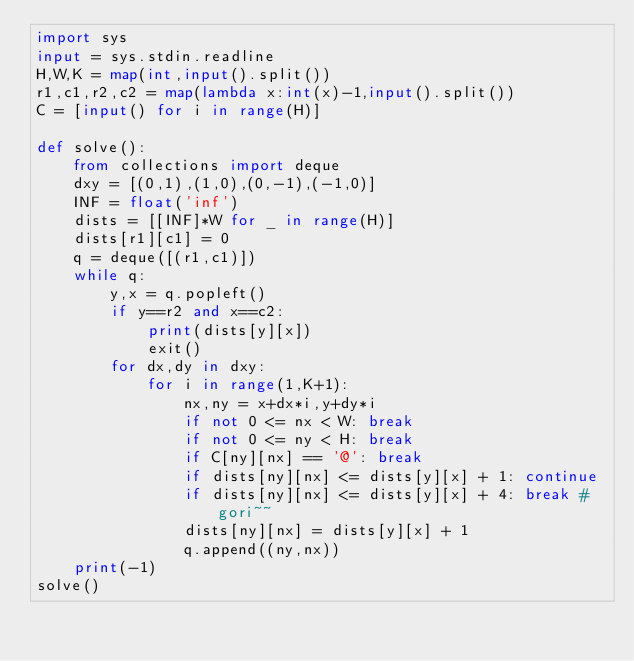Convert code to text. <code><loc_0><loc_0><loc_500><loc_500><_Python_>import sys
input = sys.stdin.readline
H,W,K = map(int,input().split())
r1,c1,r2,c2 = map(lambda x:int(x)-1,input().split())
C = [input() for i in range(H)]

def solve():
    from collections import deque
    dxy = [(0,1),(1,0),(0,-1),(-1,0)]
    INF = float('inf')
    dists = [[INF]*W for _ in range(H)]
    dists[r1][c1] = 0
    q = deque([(r1,c1)])
    while q:
        y,x = q.popleft()
        if y==r2 and x==c2:
            print(dists[y][x])
            exit()
        for dx,dy in dxy:
            for i in range(1,K+1):
                nx,ny = x+dx*i,y+dy*i
                if not 0 <= nx < W: break
                if not 0 <= ny < H: break
                if C[ny][nx] == '@': break
                if dists[ny][nx] <= dists[y][x] + 1: continue
                if dists[ny][nx] <= dists[y][x] + 4: break # gori~~
                dists[ny][nx] = dists[y][x] + 1
                q.append((ny,nx))
    print(-1)
solve()</code> 